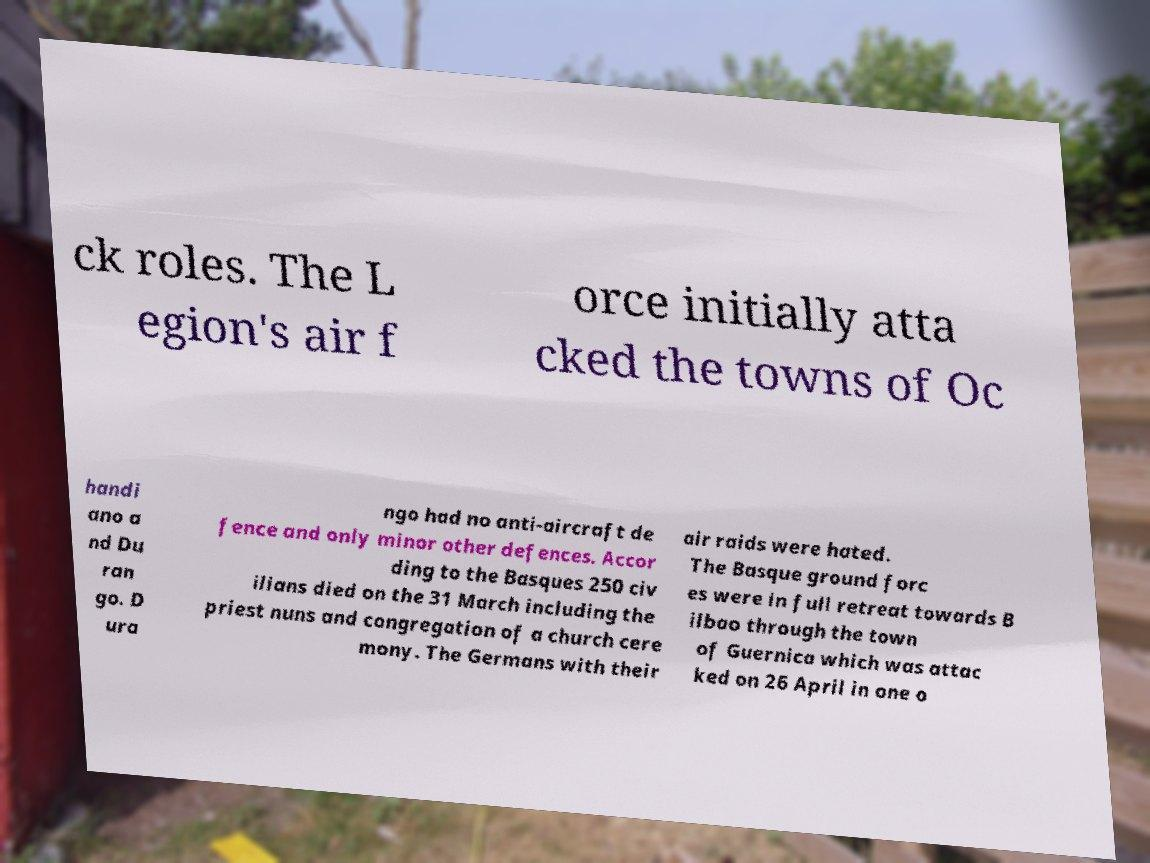For documentation purposes, I need the text within this image transcribed. Could you provide that? ck roles. The L egion's air f orce initially atta cked the towns of Oc handi ano a nd Du ran go. D ura ngo had no anti-aircraft de fence and only minor other defences. Accor ding to the Basques 250 civ ilians died on the 31 March including the priest nuns and congregation of a church cere mony. The Germans with their air raids were hated. The Basque ground forc es were in full retreat towards B ilbao through the town of Guernica which was attac ked on 26 April in one o 